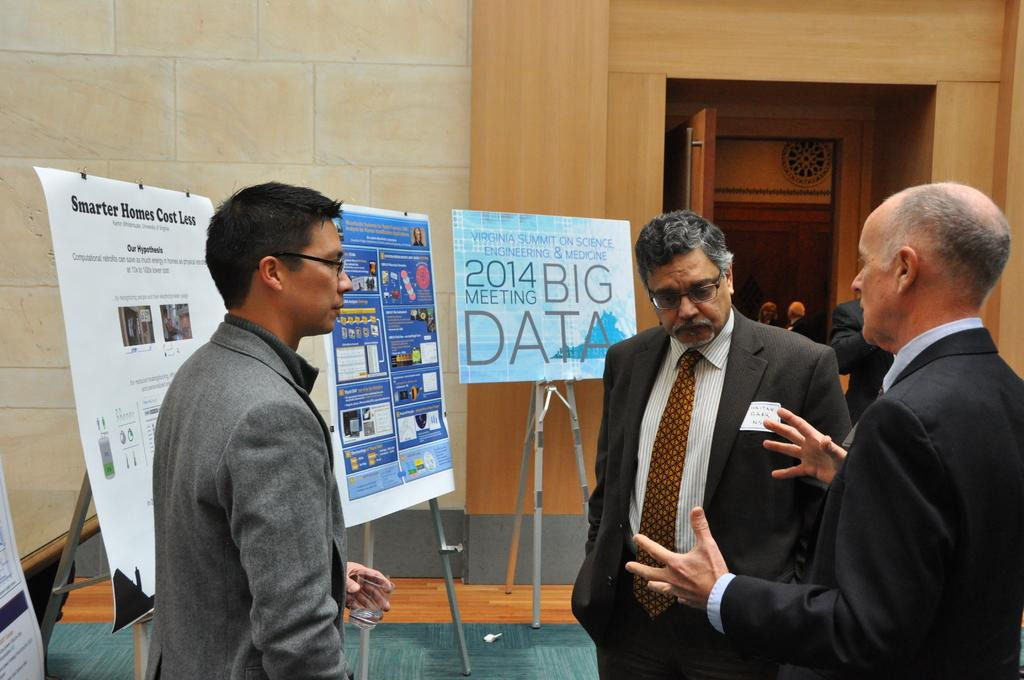How many people are standing in the image? There are three people standing in the image. What is one of the people doing? A man is talking. What can be seen in the image besides the people? There are boards with stands, the floor, a wall, and people in the background of the image. What architectural feature is visible in the background? There is a door in the background of the image. What type of wood is the authority figure using to answer the question in the image? There is no authority figure or question present in the image, and therefore no such interaction can be observed. 